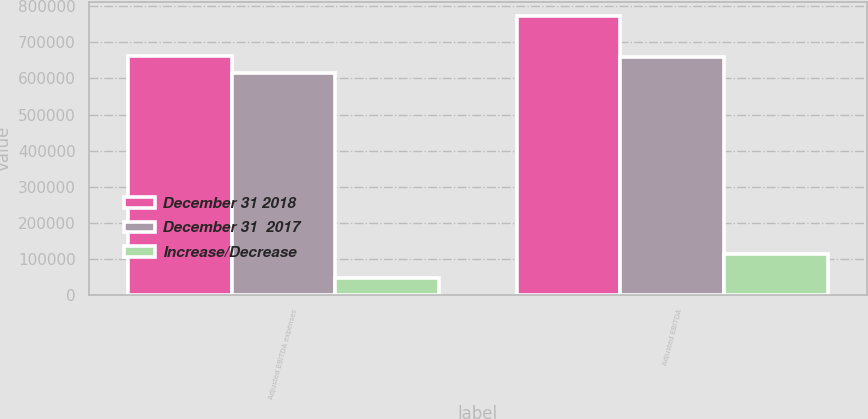Convert chart to OTSL. <chart><loc_0><loc_0><loc_500><loc_500><stacked_bar_chart><ecel><fcel>Adjusted EBITDA expenses<fcel>Adjusted EBITDA<nl><fcel>December 31 2018<fcel>661551<fcel>772433<nl><fcel>December 31  2017<fcel>614415<fcel>659757<nl><fcel>Increase/Decrease<fcel>47136<fcel>112676<nl></chart> 